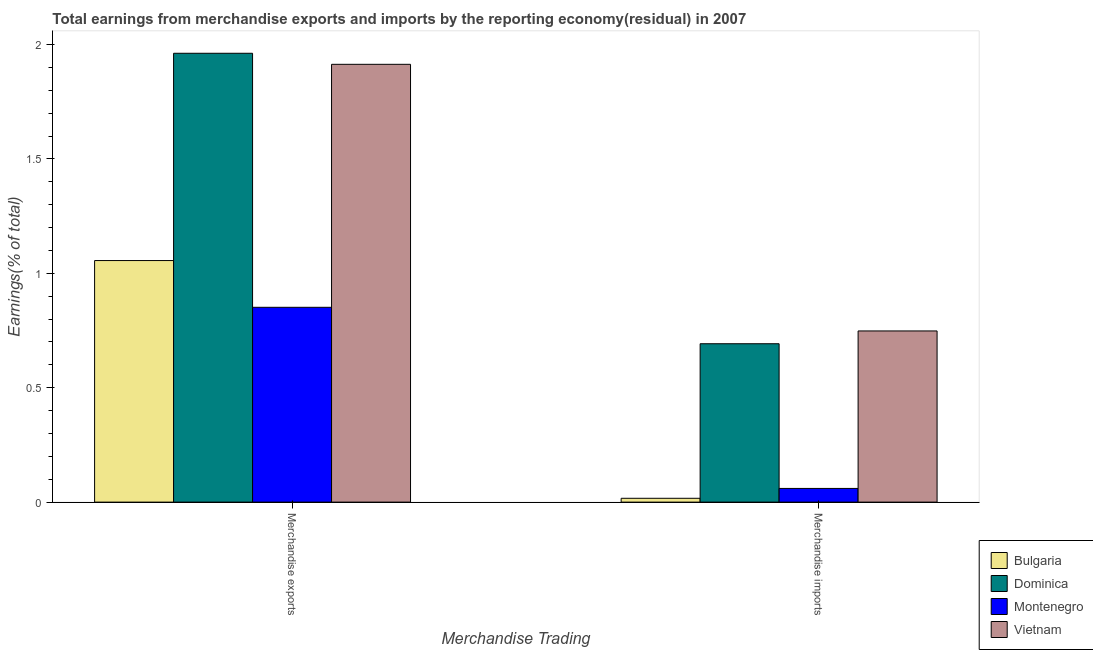Are the number of bars on each tick of the X-axis equal?
Make the answer very short. Yes. How many bars are there on the 1st tick from the right?
Keep it short and to the point. 4. What is the earnings from merchandise exports in Bulgaria?
Make the answer very short. 1.06. Across all countries, what is the maximum earnings from merchandise exports?
Provide a succinct answer. 1.96. Across all countries, what is the minimum earnings from merchandise imports?
Provide a short and direct response. 0.02. In which country was the earnings from merchandise imports maximum?
Offer a very short reply. Vietnam. In which country was the earnings from merchandise exports minimum?
Your response must be concise. Montenegro. What is the total earnings from merchandise exports in the graph?
Provide a succinct answer. 5.78. What is the difference between the earnings from merchandise exports in Montenegro and that in Vietnam?
Provide a succinct answer. -1.06. What is the difference between the earnings from merchandise exports in Vietnam and the earnings from merchandise imports in Dominica?
Give a very brief answer. 1.22. What is the average earnings from merchandise exports per country?
Provide a succinct answer. 1.45. What is the difference between the earnings from merchandise imports and earnings from merchandise exports in Dominica?
Keep it short and to the point. -1.27. What is the ratio of the earnings from merchandise exports in Bulgaria to that in Montenegro?
Ensure brevity in your answer.  1.24. Is the earnings from merchandise exports in Dominica less than that in Montenegro?
Provide a short and direct response. No. What does the 2nd bar from the left in Merchandise imports represents?
Provide a short and direct response. Dominica. What does the 3rd bar from the right in Merchandise exports represents?
Ensure brevity in your answer.  Dominica. Are all the bars in the graph horizontal?
Ensure brevity in your answer.  No. Are the values on the major ticks of Y-axis written in scientific E-notation?
Your response must be concise. No. What is the title of the graph?
Offer a terse response. Total earnings from merchandise exports and imports by the reporting economy(residual) in 2007. What is the label or title of the X-axis?
Your answer should be compact. Merchandise Trading. What is the label or title of the Y-axis?
Your response must be concise. Earnings(% of total). What is the Earnings(% of total) in Bulgaria in Merchandise exports?
Give a very brief answer. 1.06. What is the Earnings(% of total) in Dominica in Merchandise exports?
Ensure brevity in your answer.  1.96. What is the Earnings(% of total) in Montenegro in Merchandise exports?
Offer a very short reply. 0.85. What is the Earnings(% of total) of Vietnam in Merchandise exports?
Your answer should be very brief. 1.91. What is the Earnings(% of total) in Bulgaria in Merchandise imports?
Your response must be concise. 0.02. What is the Earnings(% of total) in Dominica in Merchandise imports?
Provide a succinct answer. 0.69. What is the Earnings(% of total) in Montenegro in Merchandise imports?
Provide a short and direct response. 0.06. What is the Earnings(% of total) in Vietnam in Merchandise imports?
Your answer should be compact. 0.75. Across all Merchandise Trading, what is the maximum Earnings(% of total) in Bulgaria?
Ensure brevity in your answer.  1.06. Across all Merchandise Trading, what is the maximum Earnings(% of total) of Dominica?
Offer a very short reply. 1.96. Across all Merchandise Trading, what is the maximum Earnings(% of total) of Montenegro?
Ensure brevity in your answer.  0.85. Across all Merchandise Trading, what is the maximum Earnings(% of total) of Vietnam?
Provide a succinct answer. 1.91. Across all Merchandise Trading, what is the minimum Earnings(% of total) of Bulgaria?
Your answer should be very brief. 0.02. Across all Merchandise Trading, what is the minimum Earnings(% of total) in Dominica?
Make the answer very short. 0.69. Across all Merchandise Trading, what is the minimum Earnings(% of total) of Montenegro?
Your answer should be compact. 0.06. Across all Merchandise Trading, what is the minimum Earnings(% of total) in Vietnam?
Your answer should be very brief. 0.75. What is the total Earnings(% of total) in Bulgaria in the graph?
Your answer should be compact. 1.07. What is the total Earnings(% of total) in Dominica in the graph?
Ensure brevity in your answer.  2.65. What is the total Earnings(% of total) of Montenegro in the graph?
Your response must be concise. 0.91. What is the total Earnings(% of total) of Vietnam in the graph?
Keep it short and to the point. 2.66. What is the difference between the Earnings(% of total) in Bulgaria in Merchandise exports and that in Merchandise imports?
Your answer should be very brief. 1.04. What is the difference between the Earnings(% of total) in Dominica in Merchandise exports and that in Merchandise imports?
Keep it short and to the point. 1.27. What is the difference between the Earnings(% of total) of Montenegro in Merchandise exports and that in Merchandise imports?
Offer a terse response. 0.79. What is the difference between the Earnings(% of total) in Vietnam in Merchandise exports and that in Merchandise imports?
Offer a very short reply. 1.17. What is the difference between the Earnings(% of total) of Bulgaria in Merchandise exports and the Earnings(% of total) of Dominica in Merchandise imports?
Offer a very short reply. 0.36. What is the difference between the Earnings(% of total) of Bulgaria in Merchandise exports and the Earnings(% of total) of Vietnam in Merchandise imports?
Your answer should be very brief. 0.31. What is the difference between the Earnings(% of total) of Dominica in Merchandise exports and the Earnings(% of total) of Montenegro in Merchandise imports?
Provide a succinct answer. 1.9. What is the difference between the Earnings(% of total) in Dominica in Merchandise exports and the Earnings(% of total) in Vietnam in Merchandise imports?
Offer a terse response. 1.21. What is the difference between the Earnings(% of total) of Montenegro in Merchandise exports and the Earnings(% of total) of Vietnam in Merchandise imports?
Give a very brief answer. 0.1. What is the average Earnings(% of total) of Bulgaria per Merchandise Trading?
Provide a short and direct response. 0.54. What is the average Earnings(% of total) in Dominica per Merchandise Trading?
Provide a succinct answer. 1.33. What is the average Earnings(% of total) in Montenegro per Merchandise Trading?
Offer a very short reply. 0.46. What is the average Earnings(% of total) of Vietnam per Merchandise Trading?
Provide a succinct answer. 1.33. What is the difference between the Earnings(% of total) in Bulgaria and Earnings(% of total) in Dominica in Merchandise exports?
Make the answer very short. -0.91. What is the difference between the Earnings(% of total) of Bulgaria and Earnings(% of total) of Montenegro in Merchandise exports?
Offer a terse response. 0.2. What is the difference between the Earnings(% of total) of Bulgaria and Earnings(% of total) of Vietnam in Merchandise exports?
Provide a succinct answer. -0.86. What is the difference between the Earnings(% of total) of Dominica and Earnings(% of total) of Montenegro in Merchandise exports?
Your response must be concise. 1.11. What is the difference between the Earnings(% of total) in Dominica and Earnings(% of total) in Vietnam in Merchandise exports?
Your response must be concise. 0.05. What is the difference between the Earnings(% of total) of Montenegro and Earnings(% of total) of Vietnam in Merchandise exports?
Make the answer very short. -1.06. What is the difference between the Earnings(% of total) of Bulgaria and Earnings(% of total) of Dominica in Merchandise imports?
Offer a very short reply. -0.68. What is the difference between the Earnings(% of total) in Bulgaria and Earnings(% of total) in Montenegro in Merchandise imports?
Keep it short and to the point. -0.04. What is the difference between the Earnings(% of total) of Bulgaria and Earnings(% of total) of Vietnam in Merchandise imports?
Your response must be concise. -0.73. What is the difference between the Earnings(% of total) in Dominica and Earnings(% of total) in Montenegro in Merchandise imports?
Give a very brief answer. 0.63. What is the difference between the Earnings(% of total) of Dominica and Earnings(% of total) of Vietnam in Merchandise imports?
Offer a very short reply. -0.06. What is the difference between the Earnings(% of total) of Montenegro and Earnings(% of total) of Vietnam in Merchandise imports?
Your response must be concise. -0.69. What is the ratio of the Earnings(% of total) in Bulgaria in Merchandise exports to that in Merchandise imports?
Your response must be concise. 63.05. What is the ratio of the Earnings(% of total) in Dominica in Merchandise exports to that in Merchandise imports?
Keep it short and to the point. 2.83. What is the ratio of the Earnings(% of total) in Montenegro in Merchandise exports to that in Merchandise imports?
Give a very brief answer. 14.22. What is the ratio of the Earnings(% of total) in Vietnam in Merchandise exports to that in Merchandise imports?
Make the answer very short. 2.56. What is the difference between the highest and the second highest Earnings(% of total) of Bulgaria?
Make the answer very short. 1.04. What is the difference between the highest and the second highest Earnings(% of total) in Dominica?
Provide a succinct answer. 1.27. What is the difference between the highest and the second highest Earnings(% of total) in Montenegro?
Your answer should be very brief. 0.79. What is the difference between the highest and the second highest Earnings(% of total) of Vietnam?
Offer a terse response. 1.17. What is the difference between the highest and the lowest Earnings(% of total) of Bulgaria?
Make the answer very short. 1.04. What is the difference between the highest and the lowest Earnings(% of total) in Dominica?
Your answer should be very brief. 1.27. What is the difference between the highest and the lowest Earnings(% of total) in Montenegro?
Offer a very short reply. 0.79. What is the difference between the highest and the lowest Earnings(% of total) in Vietnam?
Give a very brief answer. 1.17. 